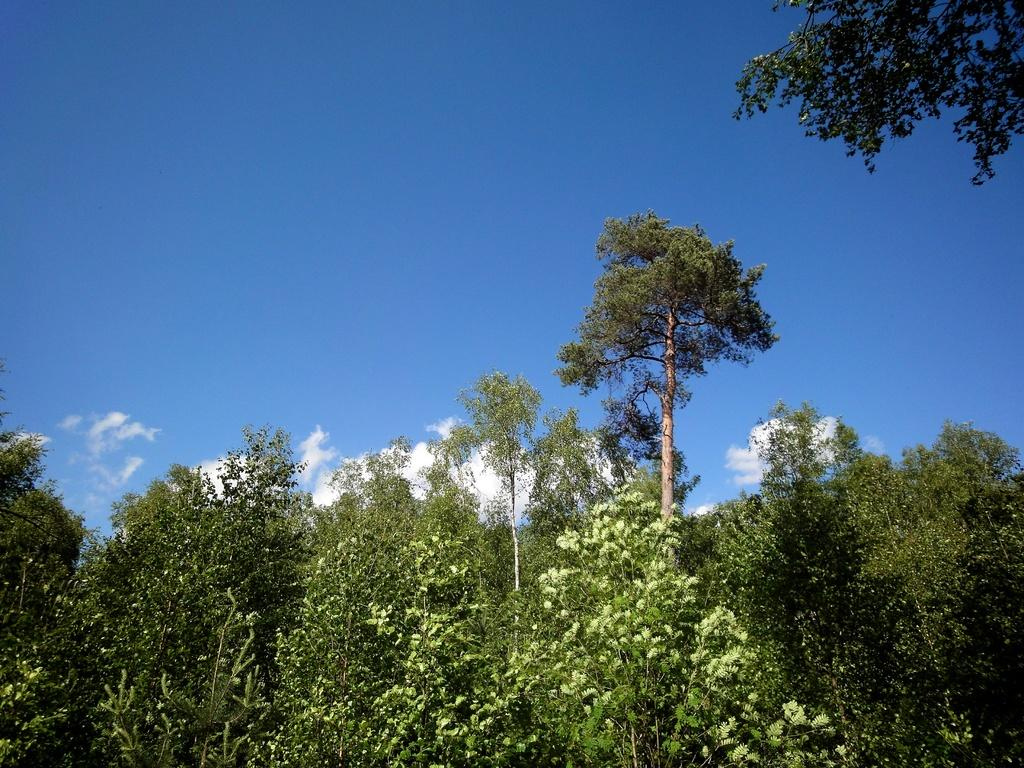What type of vegetation can be seen in the image? There are trees in the image. What can be seen in the background of the image? There are clouds and the sky visible in the background of the image. How many tomatoes are growing on the trees in the image? There are no tomatoes present in the image; it features trees without any fruits or vegetables. What type of clover can be seen in the image? There is no clover present in the image. 